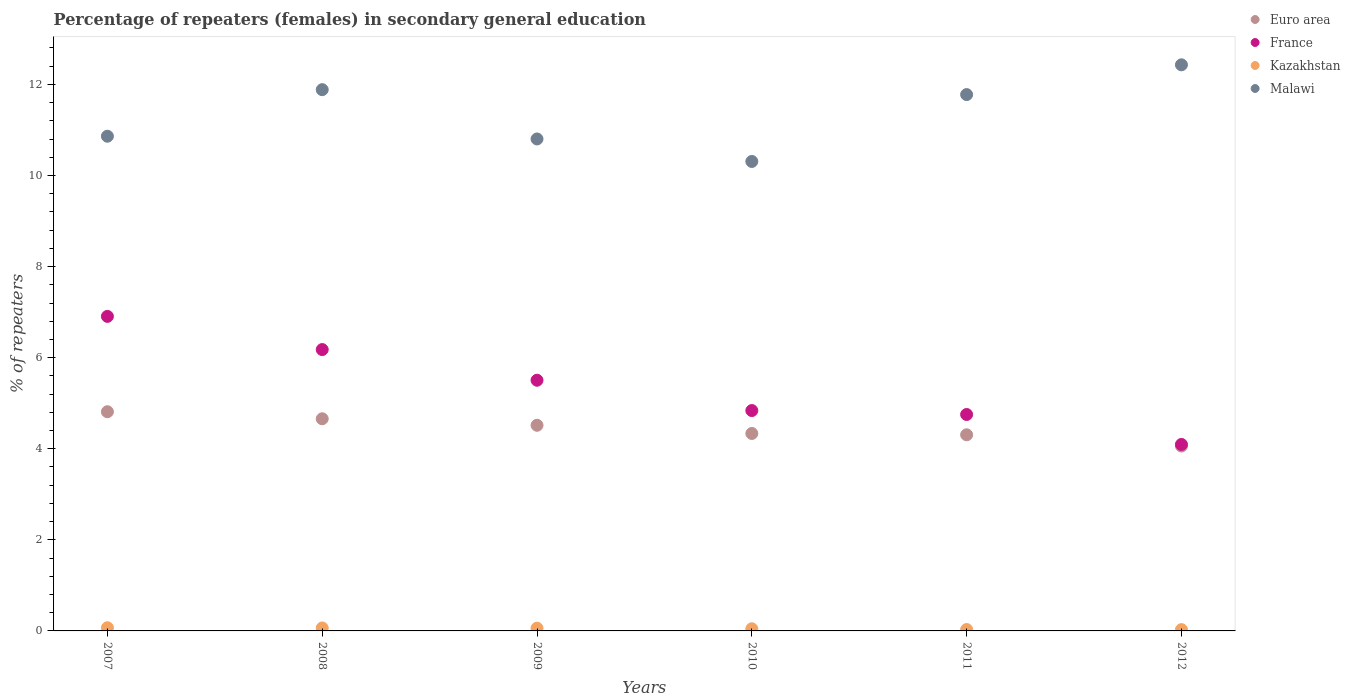Is the number of dotlines equal to the number of legend labels?
Ensure brevity in your answer.  Yes. What is the percentage of female repeaters in Malawi in 2010?
Keep it short and to the point. 10.31. Across all years, what is the maximum percentage of female repeaters in Kazakhstan?
Your response must be concise. 0.07. Across all years, what is the minimum percentage of female repeaters in Euro area?
Your response must be concise. 4.06. In which year was the percentage of female repeaters in Malawi minimum?
Make the answer very short. 2010. What is the total percentage of female repeaters in France in the graph?
Ensure brevity in your answer.  32.27. What is the difference between the percentage of female repeaters in Euro area in 2008 and that in 2010?
Your response must be concise. 0.32. What is the difference between the percentage of female repeaters in Malawi in 2009 and the percentage of female repeaters in Kazakhstan in 2007?
Your answer should be compact. 10.73. What is the average percentage of female repeaters in Malawi per year?
Give a very brief answer. 11.34. In the year 2008, what is the difference between the percentage of female repeaters in Kazakhstan and percentage of female repeaters in Malawi?
Provide a short and direct response. -11.82. In how many years, is the percentage of female repeaters in France greater than 12 %?
Provide a short and direct response. 0. What is the ratio of the percentage of female repeaters in France in 2007 to that in 2008?
Your answer should be compact. 1.12. What is the difference between the highest and the second highest percentage of female repeaters in France?
Keep it short and to the point. 0.73. What is the difference between the highest and the lowest percentage of female repeaters in France?
Your answer should be compact. 2.81. Is it the case that in every year, the sum of the percentage of female repeaters in France and percentage of female repeaters in Euro area  is greater than the sum of percentage of female repeaters in Kazakhstan and percentage of female repeaters in Malawi?
Offer a terse response. No. Is it the case that in every year, the sum of the percentage of female repeaters in France and percentage of female repeaters in Malawi  is greater than the percentage of female repeaters in Kazakhstan?
Make the answer very short. Yes. Is the percentage of female repeaters in France strictly less than the percentage of female repeaters in Malawi over the years?
Your answer should be very brief. Yes. How many dotlines are there?
Provide a short and direct response. 4. How many years are there in the graph?
Give a very brief answer. 6. How are the legend labels stacked?
Your answer should be very brief. Vertical. What is the title of the graph?
Your answer should be compact. Percentage of repeaters (females) in secondary general education. What is the label or title of the Y-axis?
Provide a short and direct response. % of repeaters. What is the % of repeaters of Euro area in 2007?
Your answer should be very brief. 4.81. What is the % of repeaters in France in 2007?
Give a very brief answer. 6.91. What is the % of repeaters of Kazakhstan in 2007?
Provide a succinct answer. 0.07. What is the % of repeaters of Malawi in 2007?
Provide a short and direct response. 10.86. What is the % of repeaters of Euro area in 2008?
Keep it short and to the point. 4.66. What is the % of repeaters in France in 2008?
Your answer should be compact. 6.18. What is the % of repeaters in Kazakhstan in 2008?
Provide a short and direct response. 0.07. What is the % of repeaters of Malawi in 2008?
Give a very brief answer. 11.88. What is the % of repeaters of Euro area in 2009?
Your answer should be compact. 4.52. What is the % of repeaters in France in 2009?
Give a very brief answer. 5.5. What is the % of repeaters of Kazakhstan in 2009?
Ensure brevity in your answer.  0.06. What is the % of repeaters of Malawi in 2009?
Make the answer very short. 10.8. What is the % of repeaters in Euro area in 2010?
Your response must be concise. 4.34. What is the % of repeaters of France in 2010?
Provide a short and direct response. 4.84. What is the % of repeaters of Kazakhstan in 2010?
Your response must be concise. 0.05. What is the % of repeaters of Malawi in 2010?
Your answer should be compact. 10.31. What is the % of repeaters of Euro area in 2011?
Offer a very short reply. 4.31. What is the % of repeaters in France in 2011?
Make the answer very short. 4.75. What is the % of repeaters of Kazakhstan in 2011?
Keep it short and to the point. 0.03. What is the % of repeaters in Malawi in 2011?
Keep it short and to the point. 11.78. What is the % of repeaters in Euro area in 2012?
Provide a short and direct response. 4.06. What is the % of repeaters of France in 2012?
Give a very brief answer. 4.09. What is the % of repeaters of Kazakhstan in 2012?
Make the answer very short. 0.03. What is the % of repeaters in Malawi in 2012?
Keep it short and to the point. 12.43. Across all years, what is the maximum % of repeaters of Euro area?
Offer a very short reply. 4.81. Across all years, what is the maximum % of repeaters of France?
Offer a very short reply. 6.91. Across all years, what is the maximum % of repeaters of Kazakhstan?
Give a very brief answer. 0.07. Across all years, what is the maximum % of repeaters of Malawi?
Offer a very short reply. 12.43. Across all years, what is the minimum % of repeaters in Euro area?
Your response must be concise. 4.06. Across all years, what is the minimum % of repeaters in France?
Offer a terse response. 4.09. Across all years, what is the minimum % of repeaters of Kazakhstan?
Ensure brevity in your answer.  0.03. Across all years, what is the minimum % of repeaters in Malawi?
Ensure brevity in your answer.  10.31. What is the total % of repeaters of Euro area in the graph?
Keep it short and to the point. 26.69. What is the total % of repeaters in France in the graph?
Your answer should be very brief. 32.27. What is the total % of repeaters in Kazakhstan in the graph?
Provide a succinct answer. 0.3. What is the total % of repeaters in Malawi in the graph?
Provide a short and direct response. 68.06. What is the difference between the % of repeaters of Euro area in 2007 and that in 2008?
Give a very brief answer. 0.15. What is the difference between the % of repeaters in France in 2007 and that in 2008?
Give a very brief answer. 0.73. What is the difference between the % of repeaters of Kazakhstan in 2007 and that in 2008?
Your response must be concise. 0. What is the difference between the % of repeaters in Malawi in 2007 and that in 2008?
Ensure brevity in your answer.  -1.02. What is the difference between the % of repeaters of Euro area in 2007 and that in 2009?
Ensure brevity in your answer.  0.3. What is the difference between the % of repeaters of France in 2007 and that in 2009?
Give a very brief answer. 1.4. What is the difference between the % of repeaters in Kazakhstan in 2007 and that in 2009?
Your answer should be very brief. 0.01. What is the difference between the % of repeaters in Malawi in 2007 and that in 2009?
Offer a terse response. 0.06. What is the difference between the % of repeaters in Euro area in 2007 and that in 2010?
Make the answer very short. 0.48. What is the difference between the % of repeaters of France in 2007 and that in 2010?
Your answer should be compact. 2.07. What is the difference between the % of repeaters in Kazakhstan in 2007 and that in 2010?
Your answer should be compact. 0.02. What is the difference between the % of repeaters in Malawi in 2007 and that in 2010?
Offer a terse response. 0.55. What is the difference between the % of repeaters in Euro area in 2007 and that in 2011?
Your answer should be compact. 0.51. What is the difference between the % of repeaters in France in 2007 and that in 2011?
Your answer should be very brief. 2.15. What is the difference between the % of repeaters in Kazakhstan in 2007 and that in 2011?
Make the answer very short. 0.04. What is the difference between the % of repeaters in Malawi in 2007 and that in 2011?
Make the answer very short. -0.91. What is the difference between the % of repeaters of Euro area in 2007 and that in 2012?
Your answer should be compact. 0.75. What is the difference between the % of repeaters in France in 2007 and that in 2012?
Provide a succinct answer. 2.81. What is the difference between the % of repeaters of Kazakhstan in 2007 and that in 2012?
Your answer should be very brief. 0.04. What is the difference between the % of repeaters in Malawi in 2007 and that in 2012?
Your answer should be compact. -1.57. What is the difference between the % of repeaters in Euro area in 2008 and that in 2009?
Make the answer very short. 0.14. What is the difference between the % of repeaters of France in 2008 and that in 2009?
Offer a terse response. 0.67. What is the difference between the % of repeaters of Kazakhstan in 2008 and that in 2009?
Provide a succinct answer. 0. What is the difference between the % of repeaters of Malawi in 2008 and that in 2009?
Your response must be concise. 1.08. What is the difference between the % of repeaters in Euro area in 2008 and that in 2010?
Your answer should be very brief. 0.32. What is the difference between the % of repeaters in France in 2008 and that in 2010?
Your answer should be compact. 1.34. What is the difference between the % of repeaters in Kazakhstan in 2008 and that in 2010?
Your response must be concise. 0.02. What is the difference between the % of repeaters of Malawi in 2008 and that in 2010?
Your response must be concise. 1.58. What is the difference between the % of repeaters of Euro area in 2008 and that in 2011?
Ensure brevity in your answer.  0.35. What is the difference between the % of repeaters in France in 2008 and that in 2011?
Make the answer very short. 1.43. What is the difference between the % of repeaters of Kazakhstan in 2008 and that in 2011?
Provide a short and direct response. 0.03. What is the difference between the % of repeaters in Malawi in 2008 and that in 2011?
Ensure brevity in your answer.  0.11. What is the difference between the % of repeaters in Euro area in 2008 and that in 2012?
Provide a short and direct response. 0.6. What is the difference between the % of repeaters of France in 2008 and that in 2012?
Your response must be concise. 2.08. What is the difference between the % of repeaters in Kazakhstan in 2008 and that in 2012?
Offer a terse response. 0.04. What is the difference between the % of repeaters in Malawi in 2008 and that in 2012?
Give a very brief answer. -0.55. What is the difference between the % of repeaters in Euro area in 2009 and that in 2010?
Keep it short and to the point. 0.18. What is the difference between the % of repeaters of France in 2009 and that in 2010?
Ensure brevity in your answer.  0.67. What is the difference between the % of repeaters in Kazakhstan in 2009 and that in 2010?
Your answer should be very brief. 0.01. What is the difference between the % of repeaters of Malawi in 2009 and that in 2010?
Offer a terse response. 0.49. What is the difference between the % of repeaters in Euro area in 2009 and that in 2011?
Keep it short and to the point. 0.21. What is the difference between the % of repeaters of France in 2009 and that in 2011?
Provide a short and direct response. 0.75. What is the difference between the % of repeaters of Kazakhstan in 2009 and that in 2011?
Offer a very short reply. 0.03. What is the difference between the % of repeaters of Malawi in 2009 and that in 2011?
Ensure brevity in your answer.  -0.97. What is the difference between the % of repeaters of Euro area in 2009 and that in 2012?
Your answer should be very brief. 0.46. What is the difference between the % of repeaters in France in 2009 and that in 2012?
Make the answer very short. 1.41. What is the difference between the % of repeaters of Kazakhstan in 2009 and that in 2012?
Provide a short and direct response. 0.03. What is the difference between the % of repeaters of Malawi in 2009 and that in 2012?
Keep it short and to the point. -1.63. What is the difference between the % of repeaters of Euro area in 2010 and that in 2011?
Keep it short and to the point. 0.03. What is the difference between the % of repeaters in France in 2010 and that in 2011?
Your response must be concise. 0.09. What is the difference between the % of repeaters of Kazakhstan in 2010 and that in 2011?
Ensure brevity in your answer.  0.02. What is the difference between the % of repeaters of Malawi in 2010 and that in 2011?
Your answer should be compact. -1.47. What is the difference between the % of repeaters in Euro area in 2010 and that in 2012?
Give a very brief answer. 0.28. What is the difference between the % of repeaters of France in 2010 and that in 2012?
Offer a terse response. 0.74. What is the difference between the % of repeaters of Kazakhstan in 2010 and that in 2012?
Your answer should be compact. 0.02. What is the difference between the % of repeaters in Malawi in 2010 and that in 2012?
Give a very brief answer. -2.12. What is the difference between the % of repeaters of Euro area in 2011 and that in 2012?
Provide a succinct answer. 0.25. What is the difference between the % of repeaters of France in 2011 and that in 2012?
Offer a terse response. 0.66. What is the difference between the % of repeaters of Kazakhstan in 2011 and that in 2012?
Give a very brief answer. 0. What is the difference between the % of repeaters in Malawi in 2011 and that in 2012?
Offer a terse response. -0.65. What is the difference between the % of repeaters of Euro area in 2007 and the % of repeaters of France in 2008?
Provide a succinct answer. -1.37. What is the difference between the % of repeaters in Euro area in 2007 and the % of repeaters in Kazakhstan in 2008?
Make the answer very short. 4.75. What is the difference between the % of repeaters of Euro area in 2007 and the % of repeaters of Malawi in 2008?
Your answer should be compact. -7.07. What is the difference between the % of repeaters in France in 2007 and the % of repeaters in Kazakhstan in 2008?
Provide a short and direct response. 6.84. What is the difference between the % of repeaters in France in 2007 and the % of repeaters in Malawi in 2008?
Keep it short and to the point. -4.98. What is the difference between the % of repeaters of Kazakhstan in 2007 and the % of repeaters of Malawi in 2008?
Give a very brief answer. -11.81. What is the difference between the % of repeaters in Euro area in 2007 and the % of repeaters in France in 2009?
Your answer should be very brief. -0.69. What is the difference between the % of repeaters of Euro area in 2007 and the % of repeaters of Kazakhstan in 2009?
Provide a succinct answer. 4.75. What is the difference between the % of repeaters of Euro area in 2007 and the % of repeaters of Malawi in 2009?
Offer a terse response. -5.99. What is the difference between the % of repeaters of France in 2007 and the % of repeaters of Kazakhstan in 2009?
Ensure brevity in your answer.  6.85. What is the difference between the % of repeaters in France in 2007 and the % of repeaters in Malawi in 2009?
Your answer should be compact. -3.9. What is the difference between the % of repeaters in Kazakhstan in 2007 and the % of repeaters in Malawi in 2009?
Your answer should be very brief. -10.73. What is the difference between the % of repeaters of Euro area in 2007 and the % of repeaters of France in 2010?
Your answer should be very brief. -0.03. What is the difference between the % of repeaters in Euro area in 2007 and the % of repeaters in Kazakhstan in 2010?
Provide a succinct answer. 4.77. What is the difference between the % of repeaters of Euro area in 2007 and the % of repeaters of Malawi in 2010?
Offer a terse response. -5.5. What is the difference between the % of repeaters in France in 2007 and the % of repeaters in Kazakhstan in 2010?
Ensure brevity in your answer.  6.86. What is the difference between the % of repeaters of France in 2007 and the % of repeaters of Malawi in 2010?
Provide a short and direct response. -3.4. What is the difference between the % of repeaters in Kazakhstan in 2007 and the % of repeaters in Malawi in 2010?
Keep it short and to the point. -10.24. What is the difference between the % of repeaters of Euro area in 2007 and the % of repeaters of France in 2011?
Offer a very short reply. 0.06. What is the difference between the % of repeaters of Euro area in 2007 and the % of repeaters of Kazakhstan in 2011?
Your answer should be very brief. 4.78. What is the difference between the % of repeaters of Euro area in 2007 and the % of repeaters of Malawi in 2011?
Ensure brevity in your answer.  -6.96. What is the difference between the % of repeaters in France in 2007 and the % of repeaters in Kazakhstan in 2011?
Make the answer very short. 6.88. What is the difference between the % of repeaters of France in 2007 and the % of repeaters of Malawi in 2011?
Ensure brevity in your answer.  -4.87. What is the difference between the % of repeaters of Kazakhstan in 2007 and the % of repeaters of Malawi in 2011?
Offer a terse response. -11.71. What is the difference between the % of repeaters of Euro area in 2007 and the % of repeaters of France in 2012?
Keep it short and to the point. 0.72. What is the difference between the % of repeaters in Euro area in 2007 and the % of repeaters in Kazakhstan in 2012?
Make the answer very short. 4.78. What is the difference between the % of repeaters in Euro area in 2007 and the % of repeaters in Malawi in 2012?
Provide a succinct answer. -7.62. What is the difference between the % of repeaters of France in 2007 and the % of repeaters of Kazakhstan in 2012?
Offer a terse response. 6.88. What is the difference between the % of repeaters of France in 2007 and the % of repeaters of Malawi in 2012?
Provide a succinct answer. -5.52. What is the difference between the % of repeaters in Kazakhstan in 2007 and the % of repeaters in Malawi in 2012?
Your answer should be very brief. -12.36. What is the difference between the % of repeaters in Euro area in 2008 and the % of repeaters in France in 2009?
Give a very brief answer. -0.85. What is the difference between the % of repeaters in Euro area in 2008 and the % of repeaters in Kazakhstan in 2009?
Offer a very short reply. 4.6. What is the difference between the % of repeaters in Euro area in 2008 and the % of repeaters in Malawi in 2009?
Offer a very short reply. -6.14. What is the difference between the % of repeaters in France in 2008 and the % of repeaters in Kazakhstan in 2009?
Provide a succinct answer. 6.12. What is the difference between the % of repeaters of France in 2008 and the % of repeaters of Malawi in 2009?
Keep it short and to the point. -4.62. What is the difference between the % of repeaters in Kazakhstan in 2008 and the % of repeaters in Malawi in 2009?
Offer a very short reply. -10.74. What is the difference between the % of repeaters in Euro area in 2008 and the % of repeaters in France in 2010?
Provide a succinct answer. -0.18. What is the difference between the % of repeaters of Euro area in 2008 and the % of repeaters of Kazakhstan in 2010?
Your answer should be very brief. 4.61. What is the difference between the % of repeaters of Euro area in 2008 and the % of repeaters of Malawi in 2010?
Make the answer very short. -5.65. What is the difference between the % of repeaters of France in 2008 and the % of repeaters of Kazakhstan in 2010?
Your answer should be very brief. 6.13. What is the difference between the % of repeaters of France in 2008 and the % of repeaters of Malawi in 2010?
Keep it short and to the point. -4.13. What is the difference between the % of repeaters in Kazakhstan in 2008 and the % of repeaters in Malawi in 2010?
Offer a terse response. -10.24. What is the difference between the % of repeaters of Euro area in 2008 and the % of repeaters of France in 2011?
Ensure brevity in your answer.  -0.09. What is the difference between the % of repeaters in Euro area in 2008 and the % of repeaters in Kazakhstan in 2011?
Offer a very short reply. 4.63. What is the difference between the % of repeaters of Euro area in 2008 and the % of repeaters of Malawi in 2011?
Give a very brief answer. -7.12. What is the difference between the % of repeaters in France in 2008 and the % of repeaters in Kazakhstan in 2011?
Keep it short and to the point. 6.15. What is the difference between the % of repeaters of France in 2008 and the % of repeaters of Malawi in 2011?
Keep it short and to the point. -5.6. What is the difference between the % of repeaters in Kazakhstan in 2008 and the % of repeaters in Malawi in 2011?
Provide a short and direct response. -11.71. What is the difference between the % of repeaters in Euro area in 2008 and the % of repeaters in France in 2012?
Offer a terse response. 0.56. What is the difference between the % of repeaters in Euro area in 2008 and the % of repeaters in Kazakhstan in 2012?
Ensure brevity in your answer.  4.63. What is the difference between the % of repeaters in Euro area in 2008 and the % of repeaters in Malawi in 2012?
Provide a succinct answer. -7.77. What is the difference between the % of repeaters of France in 2008 and the % of repeaters of Kazakhstan in 2012?
Offer a very short reply. 6.15. What is the difference between the % of repeaters of France in 2008 and the % of repeaters of Malawi in 2012?
Provide a succinct answer. -6.25. What is the difference between the % of repeaters in Kazakhstan in 2008 and the % of repeaters in Malawi in 2012?
Make the answer very short. -12.36. What is the difference between the % of repeaters of Euro area in 2009 and the % of repeaters of France in 2010?
Ensure brevity in your answer.  -0.32. What is the difference between the % of repeaters of Euro area in 2009 and the % of repeaters of Kazakhstan in 2010?
Your response must be concise. 4.47. What is the difference between the % of repeaters of Euro area in 2009 and the % of repeaters of Malawi in 2010?
Make the answer very short. -5.79. What is the difference between the % of repeaters in France in 2009 and the % of repeaters in Kazakhstan in 2010?
Provide a succinct answer. 5.46. What is the difference between the % of repeaters of France in 2009 and the % of repeaters of Malawi in 2010?
Your response must be concise. -4.8. What is the difference between the % of repeaters of Kazakhstan in 2009 and the % of repeaters of Malawi in 2010?
Your response must be concise. -10.25. What is the difference between the % of repeaters of Euro area in 2009 and the % of repeaters of France in 2011?
Provide a succinct answer. -0.24. What is the difference between the % of repeaters in Euro area in 2009 and the % of repeaters in Kazakhstan in 2011?
Your response must be concise. 4.48. What is the difference between the % of repeaters of Euro area in 2009 and the % of repeaters of Malawi in 2011?
Provide a succinct answer. -7.26. What is the difference between the % of repeaters in France in 2009 and the % of repeaters in Kazakhstan in 2011?
Offer a very short reply. 5.47. What is the difference between the % of repeaters of France in 2009 and the % of repeaters of Malawi in 2011?
Your answer should be compact. -6.27. What is the difference between the % of repeaters in Kazakhstan in 2009 and the % of repeaters in Malawi in 2011?
Your answer should be very brief. -11.72. What is the difference between the % of repeaters of Euro area in 2009 and the % of repeaters of France in 2012?
Make the answer very short. 0.42. What is the difference between the % of repeaters of Euro area in 2009 and the % of repeaters of Kazakhstan in 2012?
Give a very brief answer. 4.49. What is the difference between the % of repeaters of Euro area in 2009 and the % of repeaters of Malawi in 2012?
Give a very brief answer. -7.91. What is the difference between the % of repeaters in France in 2009 and the % of repeaters in Kazakhstan in 2012?
Give a very brief answer. 5.48. What is the difference between the % of repeaters in France in 2009 and the % of repeaters in Malawi in 2012?
Keep it short and to the point. -6.93. What is the difference between the % of repeaters in Kazakhstan in 2009 and the % of repeaters in Malawi in 2012?
Offer a terse response. -12.37. What is the difference between the % of repeaters in Euro area in 2010 and the % of repeaters in France in 2011?
Offer a very short reply. -0.42. What is the difference between the % of repeaters of Euro area in 2010 and the % of repeaters of Kazakhstan in 2011?
Ensure brevity in your answer.  4.3. What is the difference between the % of repeaters of Euro area in 2010 and the % of repeaters of Malawi in 2011?
Keep it short and to the point. -7.44. What is the difference between the % of repeaters of France in 2010 and the % of repeaters of Kazakhstan in 2011?
Your answer should be compact. 4.81. What is the difference between the % of repeaters of France in 2010 and the % of repeaters of Malawi in 2011?
Provide a short and direct response. -6.94. What is the difference between the % of repeaters of Kazakhstan in 2010 and the % of repeaters of Malawi in 2011?
Give a very brief answer. -11.73. What is the difference between the % of repeaters in Euro area in 2010 and the % of repeaters in France in 2012?
Give a very brief answer. 0.24. What is the difference between the % of repeaters in Euro area in 2010 and the % of repeaters in Kazakhstan in 2012?
Keep it short and to the point. 4.31. What is the difference between the % of repeaters in Euro area in 2010 and the % of repeaters in Malawi in 2012?
Give a very brief answer. -8.09. What is the difference between the % of repeaters of France in 2010 and the % of repeaters of Kazakhstan in 2012?
Your response must be concise. 4.81. What is the difference between the % of repeaters of France in 2010 and the % of repeaters of Malawi in 2012?
Keep it short and to the point. -7.59. What is the difference between the % of repeaters of Kazakhstan in 2010 and the % of repeaters of Malawi in 2012?
Offer a terse response. -12.38. What is the difference between the % of repeaters in Euro area in 2011 and the % of repeaters in France in 2012?
Make the answer very short. 0.21. What is the difference between the % of repeaters of Euro area in 2011 and the % of repeaters of Kazakhstan in 2012?
Your answer should be compact. 4.28. What is the difference between the % of repeaters in Euro area in 2011 and the % of repeaters in Malawi in 2012?
Provide a short and direct response. -8.12. What is the difference between the % of repeaters of France in 2011 and the % of repeaters of Kazakhstan in 2012?
Your answer should be very brief. 4.72. What is the difference between the % of repeaters of France in 2011 and the % of repeaters of Malawi in 2012?
Make the answer very short. -7.68. What is the difference between the % of repeaters in Kazakhstan in 2011 and the % of repeaters in Malawi in 2012?
Provide a succinct answer. -12.4. What is the average % of repeaters of Euro area per year?
Give a very brief answer. 4.45. What is the average % of repeaters in France per year?
Your response must be concise. 5.38. What is the average % of repeaters in Kazakhstan per year?
Offer a very short reply. 0.05. What is the average % of repeaters in Malawi per year?
Offer a very short reply. 11.34. In the year 2007, what is the difference between the % of repeaters of Euro area and % of repeaters of France?
Ensure brevity in your answer.  -2.09. In the year 2007, what is the difference between the % of repeaters in Euro area and % of repeaters in Kazakhstan?
Offer a terse response. 4.74. In the year 2007, what is the difference between the % of repeaters in Euro area and % of repeaters in Malawi?
Provide a succinct answer. -6.05. In the year 2007, what is the difference between the % of repeaters in France and % of repeaters in Kazakhstan?
Offer a terse response. 6.84. In the year 2007, what is the difference between the % of repeaters in France and % of repeaters in Malawi?
Give a very brief answer. -3.96. In the year 2007, what is the difference between the % of repeaters in Kazakhstan and % of repeaters in Malawi?
Keep it short and to the point. -10.79. In the year 2008, what is the difference between the % of repeaters of Euro area and % of repeaters of France?
Offer a very short reply. -1.52. In the year 2008, what is the difference between the % of repeaters of Euro area and % of repeaters of Kazakhstan?
Your answer should be very brief. 4.59. In the year 2008, what is the difference between the % of repeaters of Euro area and % of repeaters of Malawi?
Provide a succinct answer. -7.23. In the year 2008, what is the difference between the % of repeaters in France and % of repeaters in Kazakhstan?
Give a very brief answer. 6.11. In the year 2008, what is the difference between the % of repeaters in France and % of repeaters in Malawi?
Your response must be concise. -5.71. In the year 2008, what is the difference between the % of repeaters of Kazakhstan and % of repeaters of Malawi?
Make the answer very short. -11.82. In the year 2009, what is the difference between the % of repeaters in Euro area and % of repeaters in France?
Give a very brief answer. -0.99. In the year 2009, what is the difference between the % of repeaters of Euro area and % of repeaters of Kazakhstan?
Your answer should be compact. 4.45. In the year 2009, what is the difference between the % of repeaters in Euro area and % of repeaters in Malawi?
Provide a short and direct response. -6.29. In the year 2009, what is the difference between the % of repeaters of France and % of repeaters of Kazakhstan?
Your response must be concise. 5.44. In the year 2009, what is the difference between the % of repeaters in France and % of repeaters in Malawi?
Provide a short and direct response. -5.3. In the year 2009, what is the difference between the % of repeaters in Kazakhstan and % of repeaters in Malawi?
Offer a terse response. -10.74. In the year 2010, what is the difference between the % of repeaters of Euro area and % of repeaters of France?
Offer a very short reply. -0.5. In the year 2010, what is the difference between the % of repeaters of Euro area and % of repeaters of Kazakhstan?
Your answer should be very brief. 4.29. In the year 2010, what is the difference between the % of repeaters in Euro area and % of repeaters in Malawi?
Your answer should be compact. -5.97. In the year 2010, what is the difference between the % of repeaters of France and % of repeaters of Kazakhstan?
Give a very brief answer. 4.79. In the year 2010, what is the difference between the % of repeaters in France and % of repeaters in Malawi?
Your answer should be compact. -5.47. In the year 2010, what is the difference between the % of repeaters in Kazakhstan and % of repeaters in Malawi?
Your response must be concise. -10.26. In the year 2011, what is the difference between the % of repeaters in Euro area and % of repeaters in France?
Make the answer very short. -0.45. In the year 2011, what is the difference between the % of repeaters of Euro area and % of repeaters of Kazakhstan?
Give a very brief answer. 4.28. In the year 2011, what is the difference between the % of repeaters in Euro area and % of repeaters in Malawi?
Your answer should be very brief. -7.47. In the year 2011, what is the difference between the % of repeaters of France and % of repeaters of Kazakhstan?
Keep it short and to the point. 4.72. In the year 2011, what is the difference between the % of repeaters in France and % of repeaters in Malawi?
Your answer should be very brief. -7.02. In the year 2011, what is the difference between the % of repeaters of Kazakhstan and % of repeaters of Malawi?
Your answer should be compact. -11.75. In the year 2012, what is the difference between the % of repeaters of Euro area and % of repeaters of France?
Provide a succinct answer. -0.04. In the year 2012, what is the difference between the % of repeaters in Euro area and % of repeaters in Kazakhstan?
Your response must be concise. 4.03. In the year 2012, what is the difference between the % of repeaters of Euro area and % of repeaters of Malawi?
Your answer should be very brief. -8.37. In the year 2012, what is the difference between the % of repeaters of France and % of repeaters of Kazakhstan?
Provide a succinct answer. 4.07. In the year 2012, what is the difference between the % of repeaters of France and % of repeaters of Malawi?
Provide a succinct answer. -8.34. In the year 2012, what is the difference between the % of repeaters of Kazakhstan and % of repeaters of Malawi?
Provide a succinct answer. -12.4. What is the ratio of the % of repeaters in Euro area in 2007 to that in 2008?
Keep it short and to the point. 1.03. What is the ratio of the % of repeaters of France in 2007 to that in 2008?
Make the answer very short. 1.12. What is the ratio of the % of repeaters of Kazakhstan in 2007 to that in 2008?
Provide a succinct answer. 1.06. What is the ratio of the % of repeaters of Malawi in 2007 to that in 2008?
Your answer should be compact. 0.91. What is the ratio of the % of repeaters of Euro area in 2007 to that in 2009?
Your answer should be compact. 1.07. What is the ratio of the % of repeaters of France in 2007 to that in 2009?
Your answer should be compact. 1.25. What is the ratio of the % of repeaters in Kazakhstan in 2007 to that in 2009?
Keep it short and to the point. 1.15. What is the ratio of the % of repeaters of Malawi in 2007 to that in 2009?
Offer a terse response. 1.01. What is the ratio of the % of repeaters in Euro area in 2007 to that in 2010?
Your response must be concise. 1.11. What is the ratio of the % of repeaters of France in 2007 to that in 2010?
Your answer should be very brief. 1.43. What is the ratio of the % of repeaters of Kazakhstan in 2007 to that in 2010?
Provide a short and direct response. 1.48. What is the ratio of the % of repeaters in Malawi in 2007 to that in 2010?
Keep it short and to the point. 1.05. What is the ratio of the % of repeaters in Euro area in 2007 to that in 2011?
Keep it short and to the point. 1.12. What is the ratio of the % of repeaters in France in 2007 to that in 2011?
Your answer should be compact. 1.45. What is the ratio of the % of repeaters of Kazakhstan in 2007 to that in 2011?
Give a very brief answer. 2.26. What is the ratio of the % of repeaters in Malawi in 2007 to that in 2011?
Offer a very short reply. 0.92. What is the ratio of the % of repeaters in Euro area in 2007 to that in 2012?
Provide a succinct answer. 1.19. What is the ratio of the % of repeaters of France in 2007 to that in 2012?
Make the answer very short. 1.69. What is the ratio of the % of repeaters of Kazakhstan in 2007 to that in 2012?
Make the answer very short. 2.41. What is the ratio of the % of repeaters of Malawi in 2007 to that in 2012?
Provide a short and direct response. 0.87. What is the ratio of the % of repeaters of Euro area in 2008 to that in 2009?
Give a very brief answer. 1.03. What is the ratio of the % of repeaters in France in 2008 to that in 2009?
Provide a short and direct response. 1.12. What is the ratio of the % of repeaters in Kazakhstan in 2008 to that in 2009?
Provide a short and direct response. 1.08. What is the ratio of the % of repeaters of Malawi in 2008 to that in 2009?
Offer a terse response. 1.1. What is the ratio of the % of repeaters of Euro area in 2008 to that in 2010?
Make the answer very short. 1.07. What is the ratio of the % of repeaters in France in 2008 to that in 2010?
Offer a terse response. 1.28. What is the ratio of the % of repeaters of Kazakhstan in 2008 to that in 2010?
Offer a terse response. 1.39. What is the ratio of the % of repeaters of Malawi in 2008 to that in 2010?
Your answer should be compact. 1.15. What is the ratio of the % of repeaters in Euro area in 2008 to that in 2011?
Offer a terse response. 1.08. What is the ratio of the % of repeaters in France in 2008 to that in 2011?
Your answer should be very brief. 1.3. What is the ratio of the % of repeaters in Kazakhstan in 2008 to that in 2011?
Keep it short and to the point. 2.13. What is the ratio of the % of repeaters in Malawi in 2008 to that in 2011?
Give a very brief answer. 1.01. What is the ratio of the % of repeaters of Euro area in 2008 to that in 2012?
Your answer should be very brief. 1.15. What is the ratio of the % of repeaters of France in 2008 to that in 2012?
Make the answer very short. 1.51. What is the ratio of the % of repeaters of Kazakhstan in 2008 to that in 2012?
Provide a succinct answer. 2.27. What is the ratio of the % of repeaters in Malawi in 2008 to that in 2012?
Your answer should be very brief. 0.96. What is the ratio of the % of repeaters in Euro area in 2009 to that in 2010?
Offer a very short reply. 1.04. What is the ratio of the % of repeaters of France in 2009 to that in 2010?
Give a very brief answer. 1.14. What is the ratio of the % of repeaters of Kazakhstan in 2009 to that in 2010?
Your response must be concise. 1.29. What is the ratio of the % of repeaters in Malawi in 2009 to that in 2010?
Provide a succinct answer. 1.05. What is the ratio of the % of repeaters of Euro area in 2009 to that in 2011?
Offer a very short reply. 1.05. What is the ratio of the % of repeaters in France in 2009 to that in 2011?
Keep it short and to the point. 1.16. What is the ratio of the % of repeaters in Kazakhstan in 2009 to that in 2011?
Keep it short and to the point. 1.97. What is the ratio of the % of repeaters of Malawi in 2009 to that in 2011?
Offer a very short reply. 0.92. What is the ratio of the % of repeaters of Euro area in 2009 to that in 2012?
Keep it short and to the point. 1.11. What is the ratio of the % of repeaters of France in 2009 to that in 2012?
Your response must be concise. 1.34. What is the ratio of the % of repeaters of Kazakhstan in 2009 to that in 2012?
Make the answer very short. 2.1. What is the ratio of the % of repeaters of Malawi in 2009 to that in 2012?
Your answer should be very brief. 0.87. What is the ratio of the % of repeaters in Euro area in 2010 to that in 2011?
Make the answer very short. 1.01. What is the ratio of the % of repeaters of France in 2010 to that in 2011?
Offer a very short reply. 1.02. What is the ratio of the % of repeaters of Kazakhstan in 2010 to that in 2011?
Give a very brief answer. 1.53. What is the ratio of the % of repeaters of Malawi in 2010 to that in 2011?
Your answer should be compact. 0.88. What is the ratio of the % of repeaters of Euro area in 2010 to that in 2012?
Your response must be concise. 1.07. What is the ratio of the % of repeaters of France in 2010 to that in 2012?
Keep it short and to the point. 1.18. What is the ratio of the % of repeaters of Kazakhstan in 2010 to that in 2012?
Your response must be concise. 1.63. What is the ratio of the % of repeaters in Malawi in 2010 to that in 2012?
Offer a very short reply. 0.83. What is the ratio of the % of repeaters in Euro area in 2011 to that in 2012?
Ensure brevity in your answer.  1.06. What is the ratio of the % of repeaters in France in 2011 to that in 2012?
Your answer should be very brief. 1.16. What is the ratio of the % of repeaters in Kazakhstan in 2011 to that in 2012?
Ensure brevity in your answer.  1.07. What is the ratio of the % of repeaters of Malawi in 2011 to that in 2012?
Keep it short and to the point. 0.95. What is the difference between the highest and the second highest % of repeaters in Euro area?
Offer a terse response. 0.15. What is the difference between the highest and the second highest % of repeaters in France?
Your answer should be very brief. 0.73. What is the difference between the highest and the second highest % of repeaters in Kazakhstan?
Provide a short and direct response. 0. What is the difference between the highest and the second highest % of repeaters in Malawi?
Give a very brief answer. 0.55. What is the difference between the highest and the lowest % of repeaters in Euro area?
Your answer should be very brief. 0.75. What is the difference between the highest and the lowest % of repeaters in France?
Keep it short and to the point. 2.81. What is the difference between the highest and the lowest % of repeaters in Kazakhstan?
Ensure brevity in your answer.  0.04. What is the difference between the highest and the lowest % of repeaters in Malawi?
Your answer should be very brief. 2.12. 